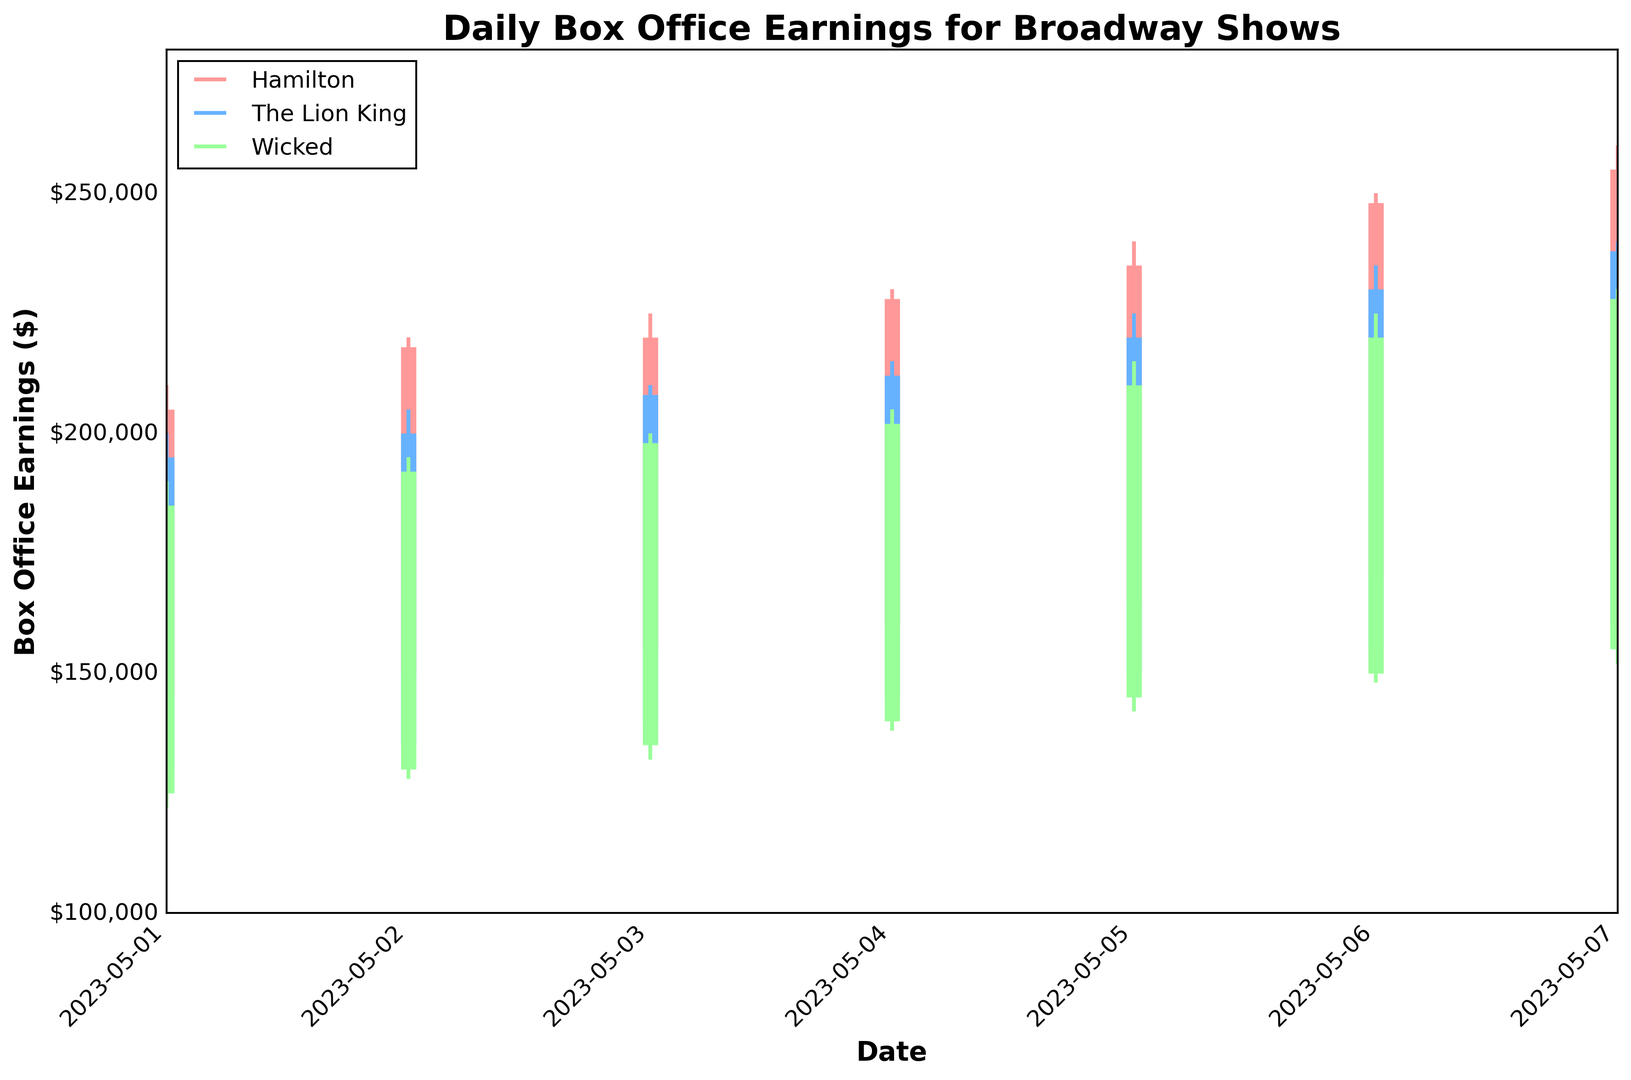What's the trend in box office earnings for Hamilton over the week? Observe the candlestick pattern for Hamilton from 2023-05-01 to 2023-05-07. The earnings consistently rise each day, with higher closing values each subsequent day.
Answer: Increasing trend Which show had the highest single-day box office earnings in the week? Compare the highest values for each show. Hamilton had the highest with $260,000 on 2023-05-07.
Answer: Hamilton ($260,000) What is the range of earnings for Wicked on 2023-05-06? Look at the high and low values for Wicked on 2023-05-06. The high is $225,000 and the low is $148,000. The range is $225,000 - $148,000 = $77,000.
Answer: $77,000 On which day did The Lion King see the greatest increase in box office earnings from the previous day? Compare the increase in closing values between consecutive days for The Lion King. From 2023-05-05 to 2023-05-06, the earnings increased from $220,000 to $230,000, a $10,000 increase, the largest observed.
Answer: 2023-05-06 How do the opening and closing values for Wicked on 2023-05-03 compare to each other? Check the open and close values for Wicked on the specified date. The opening value is $135,000 and the closing value is $198,000. The closing value is greater than the opening value by $63,000.
Answer: Closing is $63,000 higher Which show had the most consistent earnings over the week in terms of the smallest variation between daily highs and lows? Calculate the average of the daily ranges (high minus low) for each show. Wicked has ranges of [$68,000, $67,000, $66,000, $67,000, $73,000, $77,000], which indicates smaller variations compared to the other shows.
Answer: Wicked What's the average closing value for Hamilton over the week? Add the closing values for Hamilton across the seven days and divide by 7. ($205,000 + $218,000 + $220,000 + $228,000 + $235,000 + $248,000 + $255,000) / 7 = $230,714.29
Answer: $230,714.29 Which day showed the smallest gap between the low and high values for The Lion King? Calculate the difference between the high and low values for each day for The Lion King. The smallest gap is on 2023-05-01 with a difference of $72,000.
Answer: 2023-05-01 For which show and on what date did the closing value exceed the opening value the most? Calculate the difference between the opening and closing values for each show on each day. Hamilton on 2023-05-06 had the largest difference: $248,000 - $170,000 = $78,000.
Answer: Hamilton on 2023-05-06 